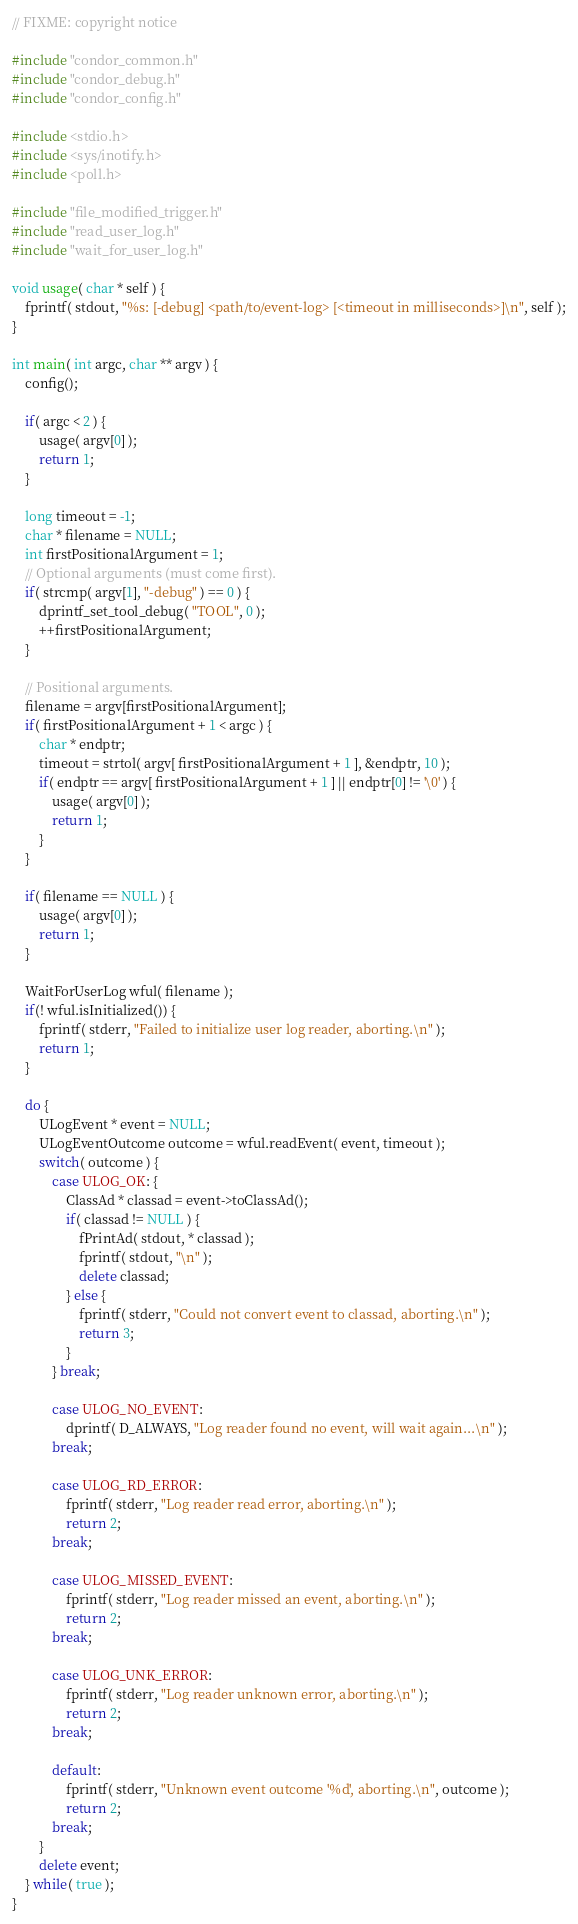Convert code to text. <code><loc_0><loc_0><loc_500><loc_500><_C++_>// FIXME: copyright notice

#include "condor_common.h"
#include "condor_debug.h"
#include "condor_config.h"

#include <stdio.h>
#include <sys/inotify.h>
#include <poll.h>

#include "file_modified_trigger.h"
#include "read_user_log.h"
#include "wait_for_user_log.h"

void usage( char * self ) {
	fprintf( stdout, "%s: [-debug] <path/to/event-log> [<timeout in milliseconds>]\n", self );
}

int main( int argc, char ** argv ) {
	config();

	if( argc < 2 ) {
		usage( argv[0] );
		return 1;
	}

	long timeout = -1;
	char * filename = NULL;
	int firstPositionalArgument = 1;
	// Optional arguments (must come first).
	if( strcmp( argv[1], "-debug" ) == 0 ) {
		dprintf_set_tool_debug( "TOOL", 0 );
		++firstPositionalArgument;
	}

	// Positional arguments.
	filename = argv[firstPositionalArgument];
	if( firstPositionalArgument + 1 < argc ) {
		char * endptr;
		timeout = strtol( argv[ firstPositionalArgument + 1 ], &endptr, 10 );
		if( endptr == argv[ firstPositionalArgument + 1 ] || endptr[0] != '\0' ) {
			usage( argv[0] );
			return 1;
		}
	}

	if( filename == NULL ) {
		usage( argv[0] );
		return 1;
	}

	WaitForUserLog wful( filename );
	if(! wful.isInitialized()) {
		fprintf( stderr, "Failed to initialize user log reader, aborting.\n" );
		return 1;
	}

	do {
		ULogEvent * event = NULL;
		ULogEventOutcome outcome = wful.readEvent( event, timeout );
		switch( outcome ) {
			case ULOG_OK: {
				ClassAd * classad = event->toClassAd();
				if( classad != NULL ) {
					fPrintAd( stdout, * classad );
					fprintf( stdout, "\n" );
					delete classad;
				} else {
					fprintf( stderr, "Could not convert event to classad, aborting.\n" );
					return 3;
				}
			} break;

			case ULOG_NO_EVENT:
				dprintf( D_ALWAYS, "Log reader found no event, will wait again...\n" );
			break;

			case ULOG_RD_ERROR:
				fprintf( stderr, "Log reader read error, aborting.\n" );
				return 2;
			break;

			case ULOG_MISSED_EVENT:
				fprintf( stderr, "Log reader missed an event, aborting.\n" );
				return 2;
			break;

			case ULOG_UNK_ERROR:
				fprintf( stderr, "Log reader unknown error, aborting.\n" );
				return 2;
			break;

			default:
				fprintf( stderr, "Unknown event outcome '%d', aborting.\n", outcome );
				return 2;
			break;
		}
		delete event;
	} while( true );
}
</code> 